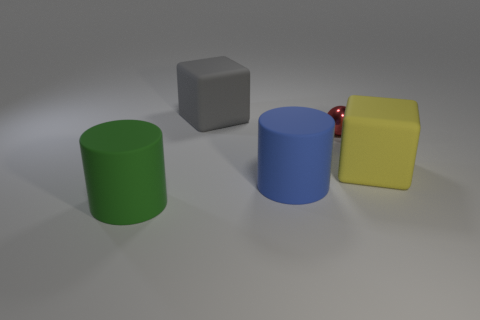Add 5 green rubber cubes. How many objects exist? 10 Subtract all red cylinders. Subtract all cyan spheres. How many cylinders are left? 2 Subtract all brown cubes. How many purple cylinders are left? 0 Subtract all red metallic things. Subtract all large cylinders. How many objects are left? 2 Add 1 big yellow rubber objects. How many big yellow rubber objects are left? 2 Add 2 large spheres. How many large spheres exist? 2 Subtract 0 purple balls. How many objects are left? 5 Subtract all balls. How many objects are left? 4 Subtract 2 cylinders. How many cylinders are left? 0 